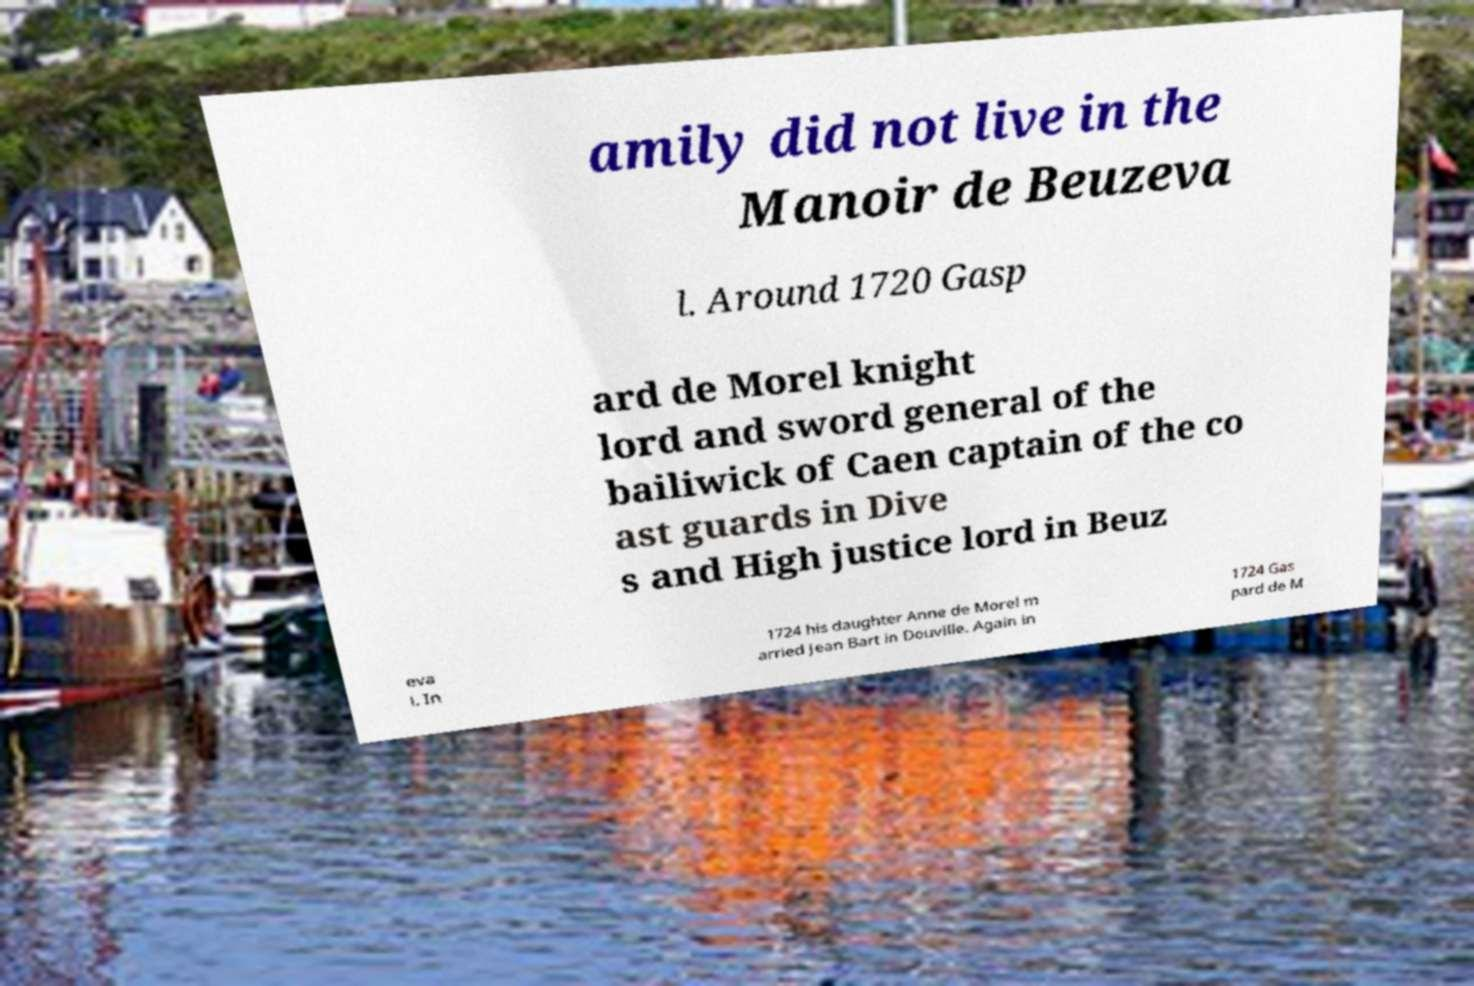What messages or text are displayed in this image? I need them in a readable, typed format. amily did not live in the Manoir de Beuzeva l. Around 1720 Gasp ard de Morel knight lord and sword general of the bailiwick of Caen captain of the co ast guards in Dive s and High justice lord in Beuz eva l. In 1724 his daughter Anne de Morel m arried Jean Bart in Douville. Again in 1724 Gas pard de M 